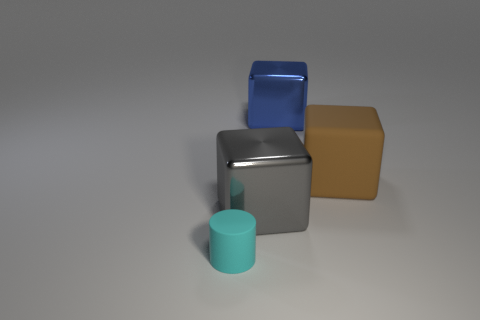How many objects are either metallic blocks in front of the large blue block or big objects behind the gray metal thing?
Provide a short and direct response. 3. What shape is the small cyan thing?
Your answer should be compact. Cylinder. How many large green cubes have the same material as the brown thing?
Give a very brief answer. 0. The big matte block has what color?
Offer a terse response. Brown. The other matte block that is the same size as the blue block is what color?
Your response must be concise. Brown. Are there any large metallic blocks that have the same color as the rubber cylinder?
Ensure brevity in your answer.  No. There is a big object that is behind the large rubber thing; is its shape the same as the matte thing that is behind the tiny rubber cylinder?
Make the answer very short. Yes. How many other things are there of the same size as the blue thing?
Your answer should be compact. 2. There is a small matte cylinder; does it have the same color as the large cube that is behind the rubber cube?
Ensure brevity in your answer.  No. Is the number of cyan things to the right of the gray shiny thing less than the number of matte cylinders in front of the small matte cylinder?
Provide a short and direct response. No. 